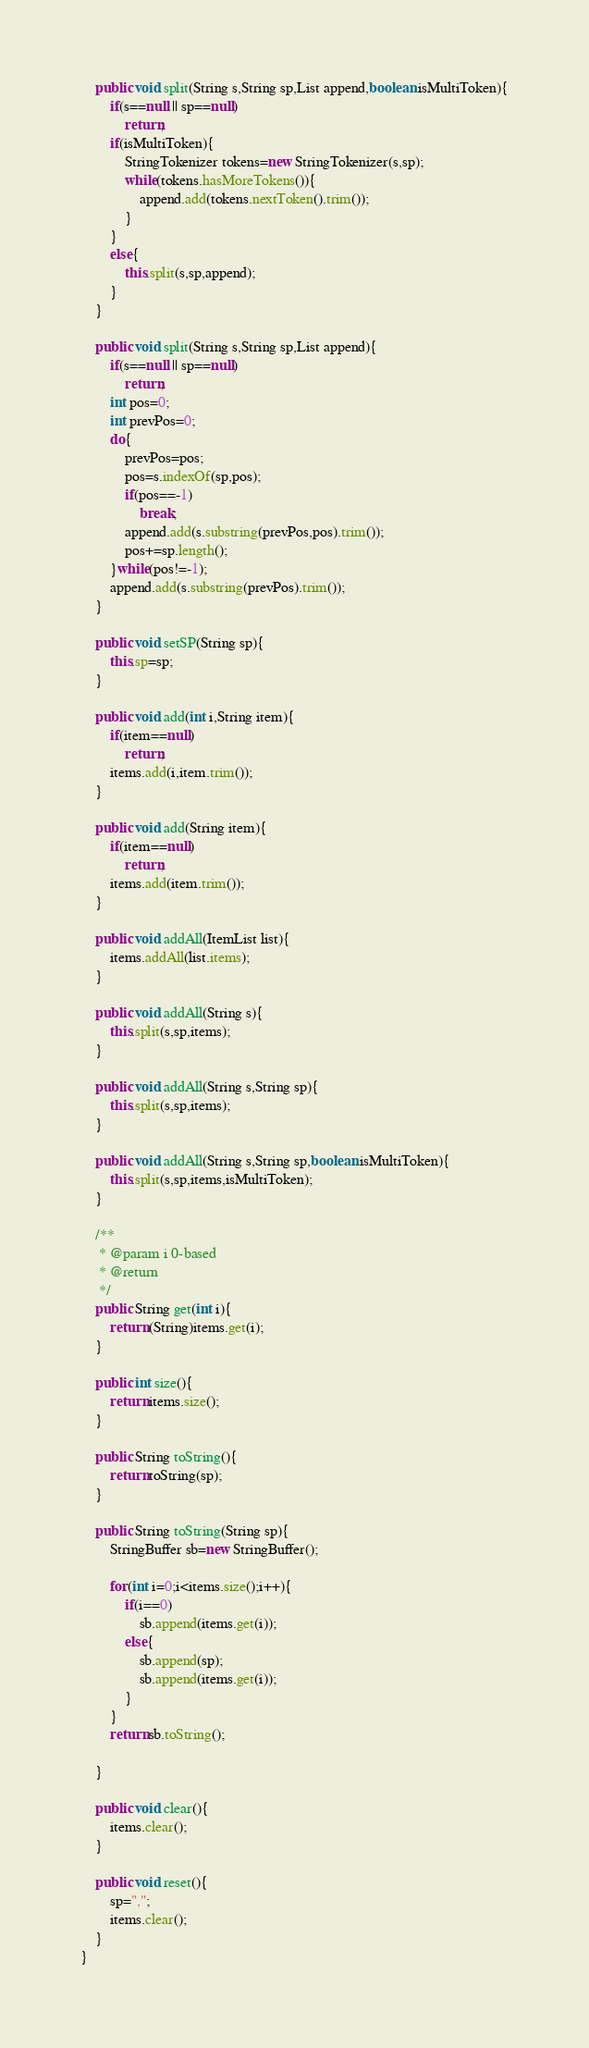<code> <loc_0><loc_0><loc_500><loc_500><_Java_>	public void split(String s,String sp,List append,boolean isMultiToken){
		if(s==null || sp==null)
			return;
		if(isMultiToken){
			StringTokenizer tokens=new StringTokenizer(s,sp);
			while(tokens.hasMoreTokens()){
				append.add(tokens.nextToken().trim());
			}
		}
		else{
			this.split(s,sp,append);
		}
	}
	
	public void split(String s,String sp,List append){
		if(s==null || sp==null)
			return;
		int pos=0;
		int prevPos=0;
		do{
			prevPos=pos;
			pos=s.indexOf(sp,pos);
			if(pos==-1)
				break;
			append.add(s.substring(prevPos,pos).trim());
			pos+=sp.length();
		}while(pos!=-1);
		append.add(s.substring(prevPos).trim());
	}
	
	public void setSP(String sp){
		this.sp=sp;
	}
	
	public void add(int i,String item){
		if(item==null)
			return;
		items.add(i,item.trim());
	}

	public void add(String item){
		if(item==null)
			return;
		items.add(item.trim());
	}
	
	public void addAll(ItemList list){
		items.addAll(list.items);
	}
	
	public void addAll(String s){
		this.split(s,sp,items);
	}
	
	public void addAll(String s,String sp){
		this.split(s,sp,items);
	}
	
	public void addAll(String s,String sp,boolean isMultiToken){
		this.split(s,sp,items,isMultiToken);
	}
	
	/**
	 * @param i 0-based
	 * @return
	 */
	public String get(int i){
		return (String)items.get(i);
	}
	
	public int size(){
		return items.size();
	}

	public String toString(){
		return toString(sp);
	}
	
	public String toString(String sp){
		StringBuffer sb=new StringBuffer();
		
		for(int i=0;i<items.size();i++){
			if(i==0)
				sb.append(items.get(i));
			else{
				sb.append(sp);
				sb.append(items.get(i));
			}
		}
		return sb.toString();

	}
	
	public void clear(){
		items.clear();
	}
	
	public void reset(){
		sp=",";
		items.clear();
	}
}
</code> 